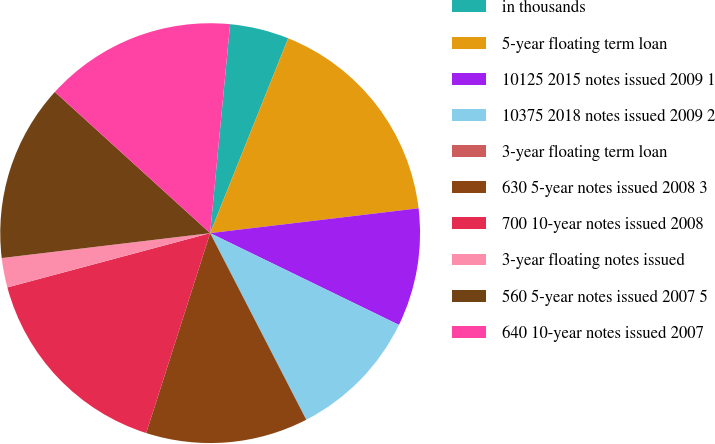<chart> <loc_0><loc_0><loc_500><loc_500><pie_chart><fcel>in thousands<fcel>5-year floating term loan<fcel>10125 2015 notes issued 2009 1<fcel>10375 2018 notes issued 2009 2<fcel>3-year floating term loan<fcel>630 5-year notes issued 2008 3<fcel>700 10-year notes issued 2008<fcel>3-year floating notes issued<fcel>560 5-year notes issued 2007 5<fcel>640 10-year notes issued 2007<nl><fcel>4.55%<fcel>17.05%<fcel>9.09%<fcel>10.23%<fcel>0.0%<fcel>12.5%<fcel>15.91%<fcel>2.27%<fcel>13.64%<fcel>14.77%<nl></chart> 